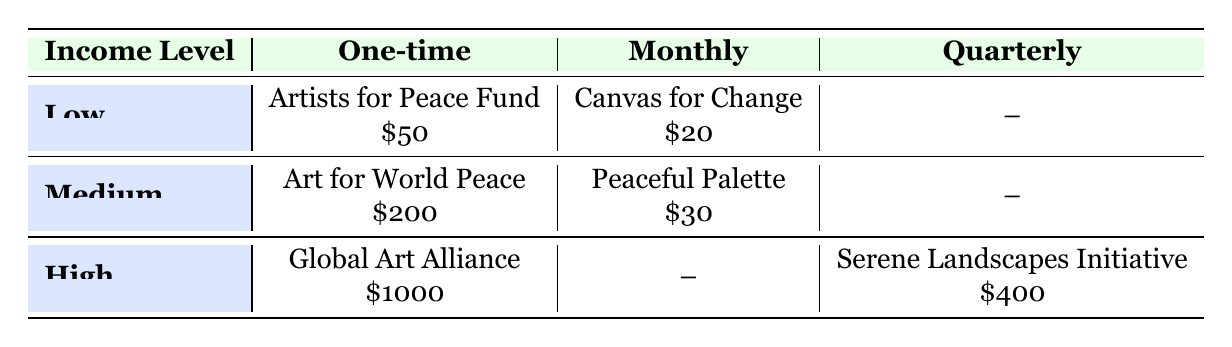What is the highest donation amount recorded in the table? The highest donation amount can be found by scanning through all the donation amounts listed for each frequency and income level. The values are $50, $20, $200, $30, $1000, and $400. The largest of these is $1000.
Answer: $1000 How many organizations receive monthly donations? To find the number of organizations receiving monthly donations, we look specifically for entries under the "Monthly" column. In the table, there are two organizations listed under this column: Canvas for Change and Peaceful Palette.
Answer: 2 Is there an organization associated with high-income level that receives monthly donations? We can check the "High" income level row in the Monthly column to see if there is an organization listed there. The table indicates no organization is listed in that category, so the answer is no.
Answer: No What is the total number of unique organizations listed in the table? The unique organizations listed are: Artists for Peace Fund, Canvas for Change, Art for World Peace, Peaceful Palette, Global Art Alliance, and Serene Landscapes Initiative. Counting these gives us six different organizations.
Answer: 6 What is the average donation amount for the medium income level? First, we identify the donations under the medium income level, which are $200 (Art for World Peace) and $30 (Peaceful Palette). We sum these amounts: 200 + 30 = 230. Then, divide by the number of donations (2) to find the average: 230 / 2 = 115.
Answer: 115 Which income level has the highest individual donation, and what is the amount? We look at each income level's highest donation. For low, it's $50; for medium, it's $200; and for high, it's $1000. The highest individual donation is $1000, which belongs to the high income level.
Answer: High income level, $1000 Is there a quarterly donation recorded in the low-income level? The low-income row must be checked for a quarterly donation. The table indicates that there is a “--” entry in the quarterly column for low-income, meaning there is no quarterly donation listed.
Answer: No What is the difference in donation amounts between the high-income one-time donation and the low-income one-time donation? We take the high-income one-time donation ($1000 from Global Art Alliance) and the low-income one-time donation ($50 from Artists for Peace Fund). To find the difference, we subtract the low from the high: 1000 - 50 = 950.
Answer: 950 